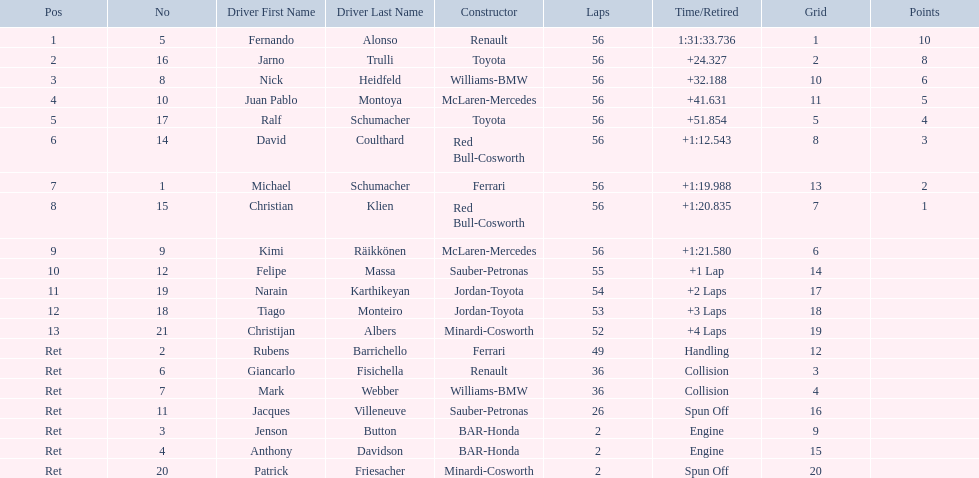What place did fernando alonso finish? 1. How long did it take alonso to finish the race? 1:31:33.736. 